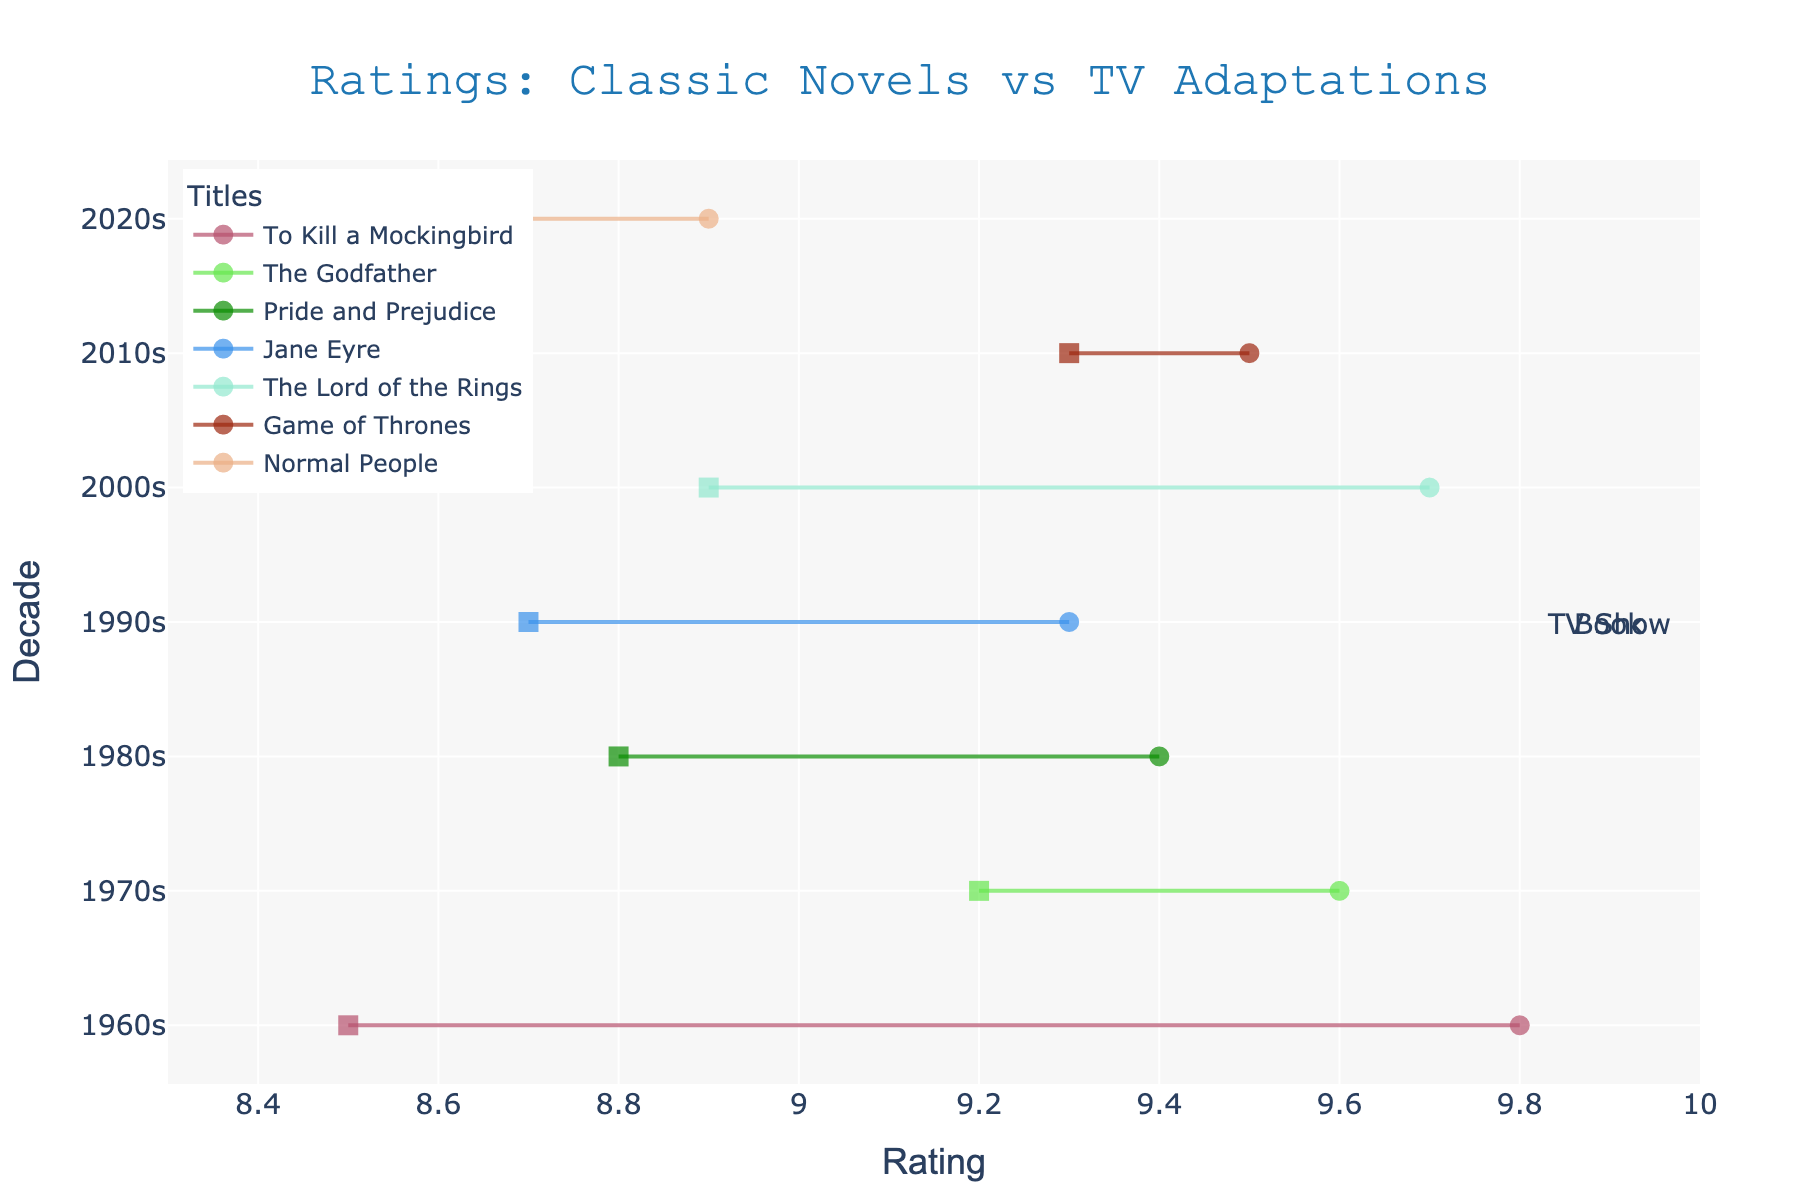what is the range of the ratings on the x-axis? The x-axis shows ratings starting at 8.3 and ending at 10.
Answer: 8.3 to 10 what is the general trend in viewing ratings for TV shows compared to their original books? The TV shows tend to have slightly lower ratings compared to the original books.
Answer: Slightly lower which decade has the smallest difference in ratings between the book and TV adaptation? For each decade, observe the lengths of the lines (dumbbells) connecting the book and TV show ratings. The 2010s, with "Game of Thrones," has the smallest difference.
Answer: 2010s which decade shows the largest difference between book and TV show ratings? The 1960s, with "To Kill a Mockingbird," has the largest difference between book and TV ratings, as indicated by a longer line connecting the ratings.
Answer: 1960s what color patterns are used to differentiate between various titles in the plot? Each title is represented by lines of unique colors with different random RGB values, and the markers for books and TV shows are of different shapes (circle and square respectively).
Answer: Unique colors and marker shapes does any TV show have a higher rating than its corresponding book? By comparing each pair of ratings, none of the TV shows have a higher rating than their corresponding books.
Answer: No how do the ratings of TV shows in the 1990s compare to those in the 2020s? The TV shows in the 1990s ("Jane Eyre") has a rating of 8.7, which is higher compared to the TV show in the 2020s ("Normal People") with a rating of 8.6.
Answer: Higher in 1990s which title from the plot has the highest book rating? By observing the ratings of all books, "To Kill a Mockingbird" from the 1960s has the highest book rating of 9.8.
Answer: To Kill a Mockingbird what are the overall ratings of "The Godfather" book and TV show in the 1970s? The book rating of "The Godfather" is 9.6, and the TV show rating is 9.2 in the 1970s.
Answer: 9.6 (Book) and 9.2 (TV Show) do the TV show ratings ever surpass 9.5? By examining the ratings provided for all TV shows, none of them have a rating that surpasses 9.5.
Answer: No 